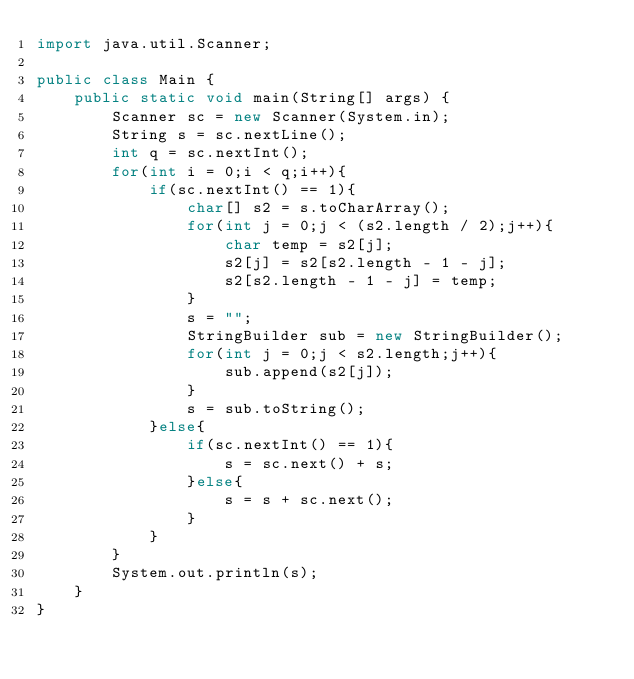<code> <loc_0><loc_0><loc_500><loc_500><_Java_>import java.util.Scanner;

public class Main {
    public static void main(String[] args) {
        Scanner sc = new Scanner(System.in);
        String s = sc.nextLine();
        int q = sc.nextInt();
        for(int i = 0;i < q;i++){
            if(sc.nextInt() == 1){
                char[] s2 = s.toCharArray();
                for(int j = 0;j < (s2.length / 2);j++){
                    char temp = s2[j];
                    s2[j] = s2[s2.length - 1 - j];
                    s2[s2.length - 1 - j] = temp;
                }
                s = "";
                StringBuilder sub = new StringBuilder();
                for(int j = 0;j < s2.length;j++){
                    sub.append(s2[j]);
                }
                s = sub.toString();
            }else{
                if(sc.nextInt() == 1){
                    s = sc.next() + s;
                }else{
                    s = s + sc.next();
                }
            }
        }
        System.out.println(s);
    }
}
</code> 